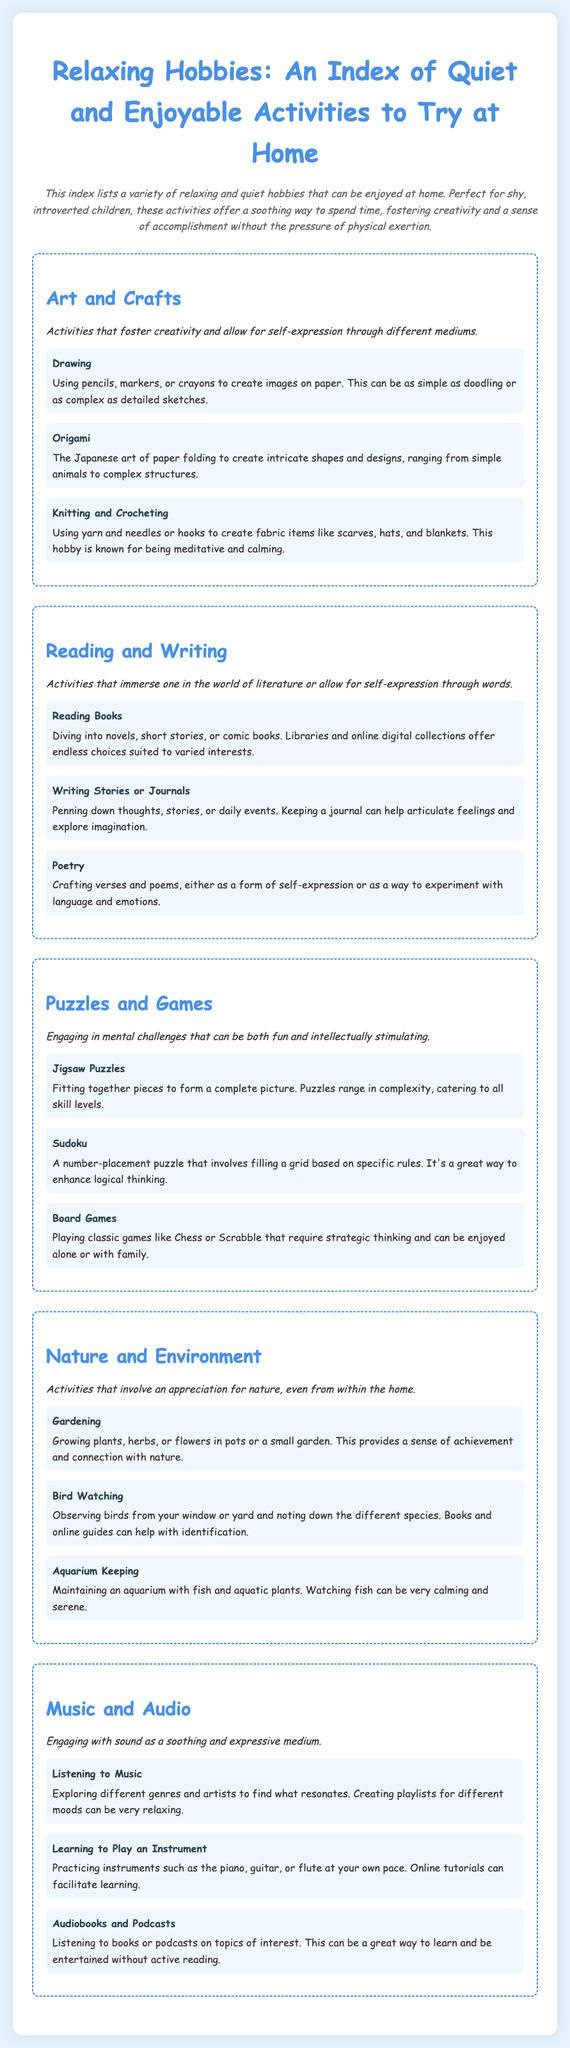What is the title of the document? The title is prominently displayed at the top of the document.
Answer: Relaxing Hobbies: An Index of Quiet and Enjoyable Activities to Try at Home How many sections are included in the index? The document outlines distinct sections that categorize hobbies, which can be counted.
Answer: 5 What is one activity listed under "Art and Crafts"? The document provides specific activities under each section, including this category.
Answer: Drawing Which hobby involves maintaining fish? This specific hobby is detailed under the "Nature and Environment" section, focusing on an activity involving aquatic life.
Answer: Aquarium Keeping What type of puzzles is mentioned in the document? The index lists specific types of puzzles categorized under "Puzzles and Games."
Answer: Jigsaw Puzzles What is a calming activity related to music? The document includes various music-related activities that are soothing and enjoyable.
Answer: Listening to Music Which section includes "Bird Watching"? The activity is categorized in a specific section that appreciates nature and the environment.
Answer: Nature and Environment How can one learn to play an instrument according to the document? The document indicates how to approach learning an instrument, specifying a resource for guidance.
Answer: Online tutorials 